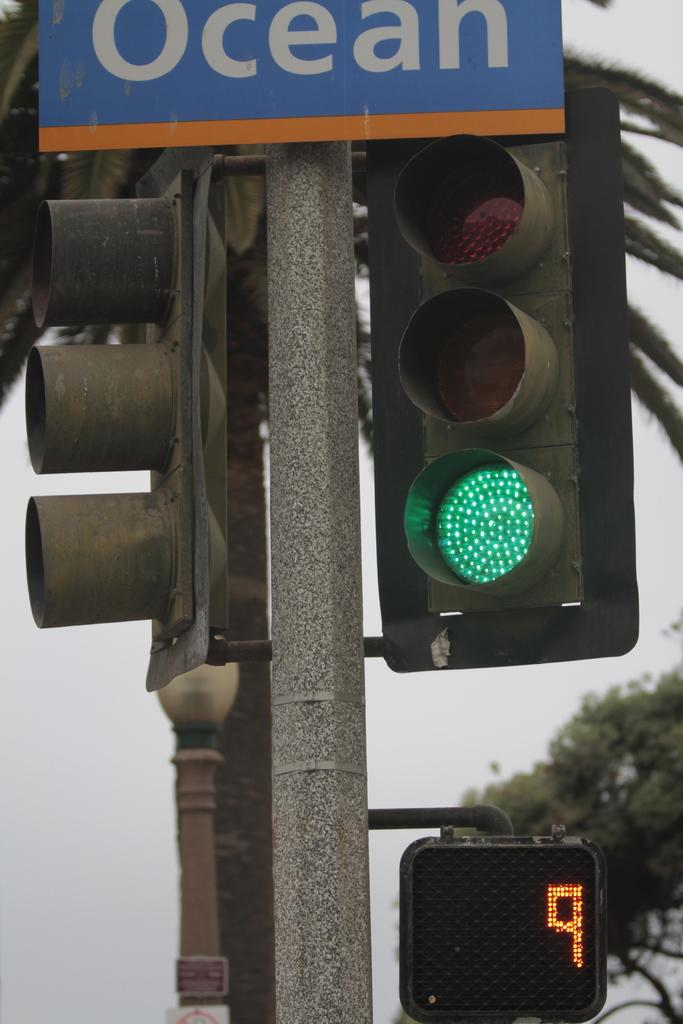<image>
Provide a brief description of the given image. A traffic light that is on green and beneath it a sign with the number 9 showing. 